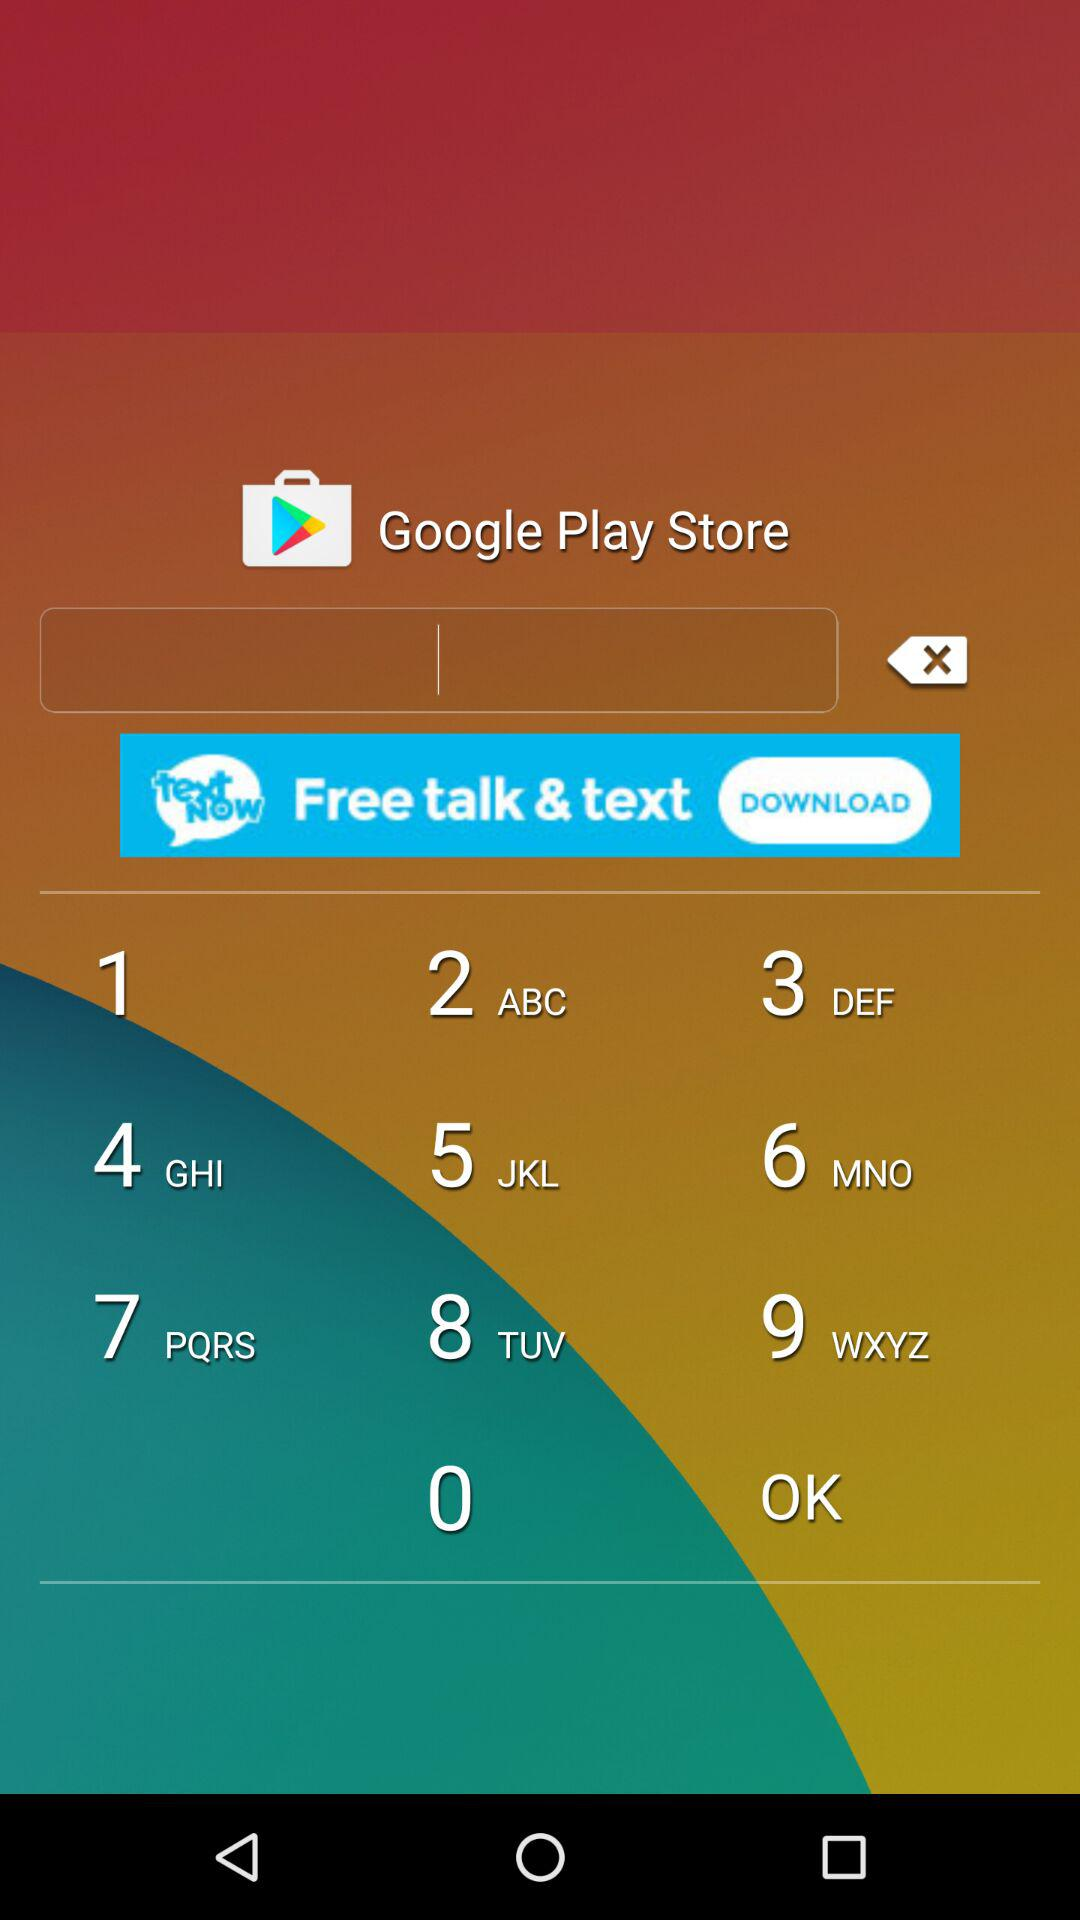How many distance units are available?
Answer the question using a single word or phrase. 2 